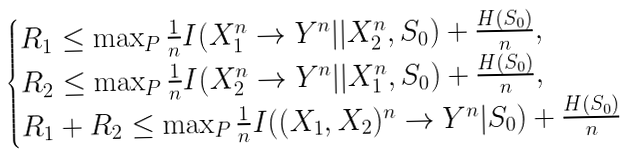<formula> <loc_0><loc_0><loc_500><loc_500>\begin{cases} R _ { 1 } \leq \max _ { P } \frac { 1 } { n } I ( X _ { 1 } ^ { n } \to Y ^ { n } | | X _ { 2 } ^ { n } , S _ { 0 } ) + \frac { H ( S _ { 0 } ) } { n } , \\ R _ { 2 } \leq \max _ { P } \frac { 1 } { n } I ( X _ { 2 } ^ { n } \to Y ^ { n } | | X _ { 1 } ^ { n } , S _ { 0 } ) + \frac { H ( S _ { 0 } ) } { n } , \\ R _ { 1 } + R _ { 2 } \leq \max _ { P } \frac { 1 } { n } I ( ( X _ { 1 } , X _ { 2 } ) ^ { n } \to Y ^ { n } | S _ { 0 } ) + \frac { H ( S _ { 0 } ) } { n } \end{cases}</formula> 